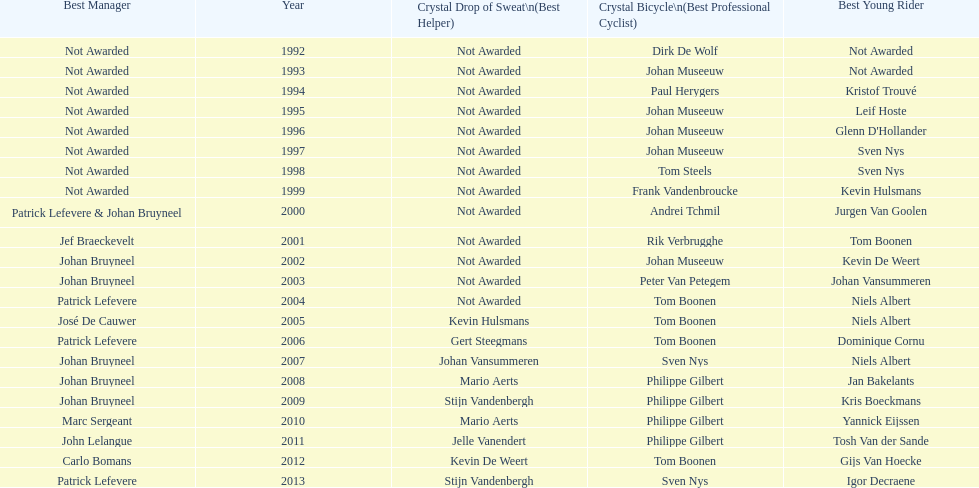Who won the most consecutive crystal bicycles? Philippe Gilbert. 